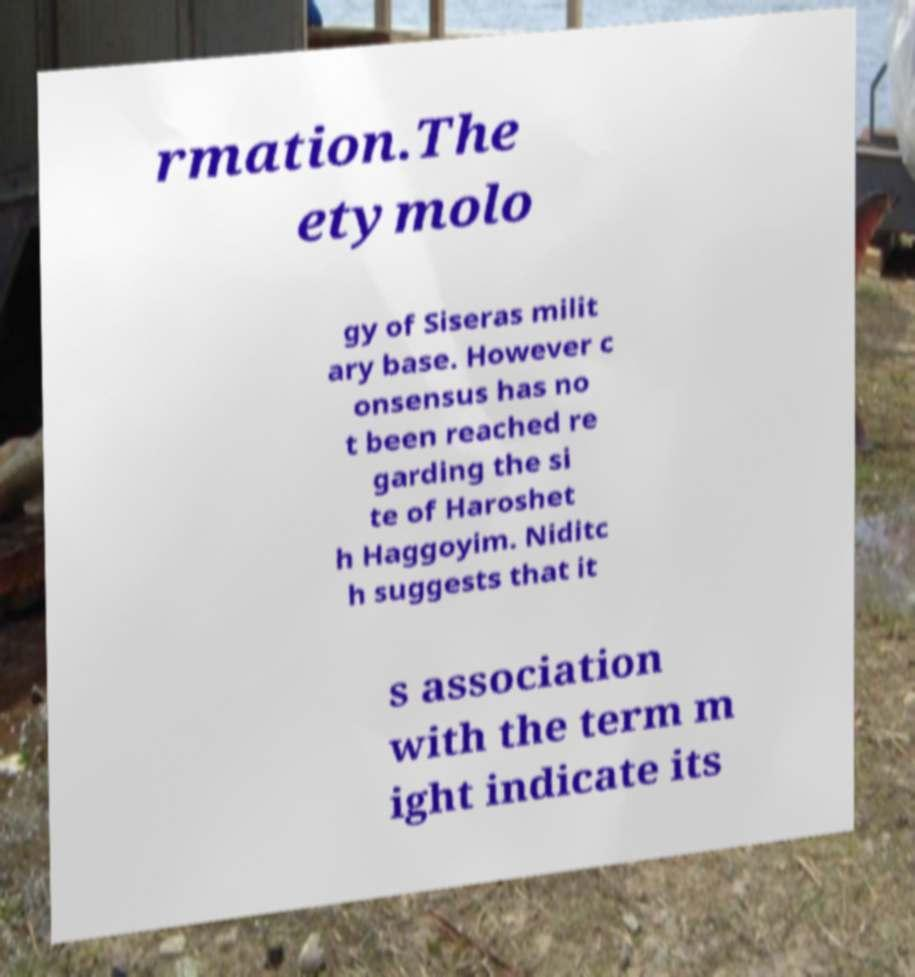I need the written content from this picture converted into text. Can you do that? rmation.The etymolo gy of Siseras milit ary base. However c onsensus has no t been reached re garding the si te of Haroshet h Haggoyim. Niditc h suggests that it s association with the term m ight indicate its 